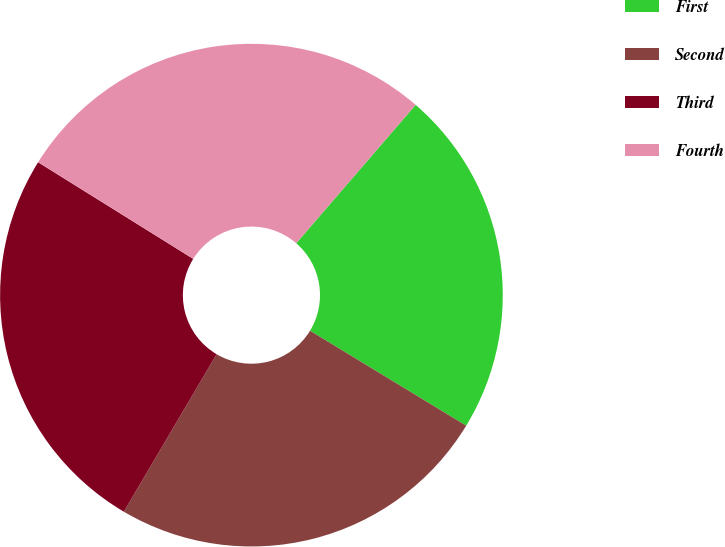Convert chart. <chart><loc_0><loc_0><loc_500><loc_500><pie_chart><fcel>First<fcel>Second<fcel>Third<fcel>Fourth<nl><fcel>22.36%<fcel>24.78%<fcel>25.39%<fcel>27.46%<nl></chart> 